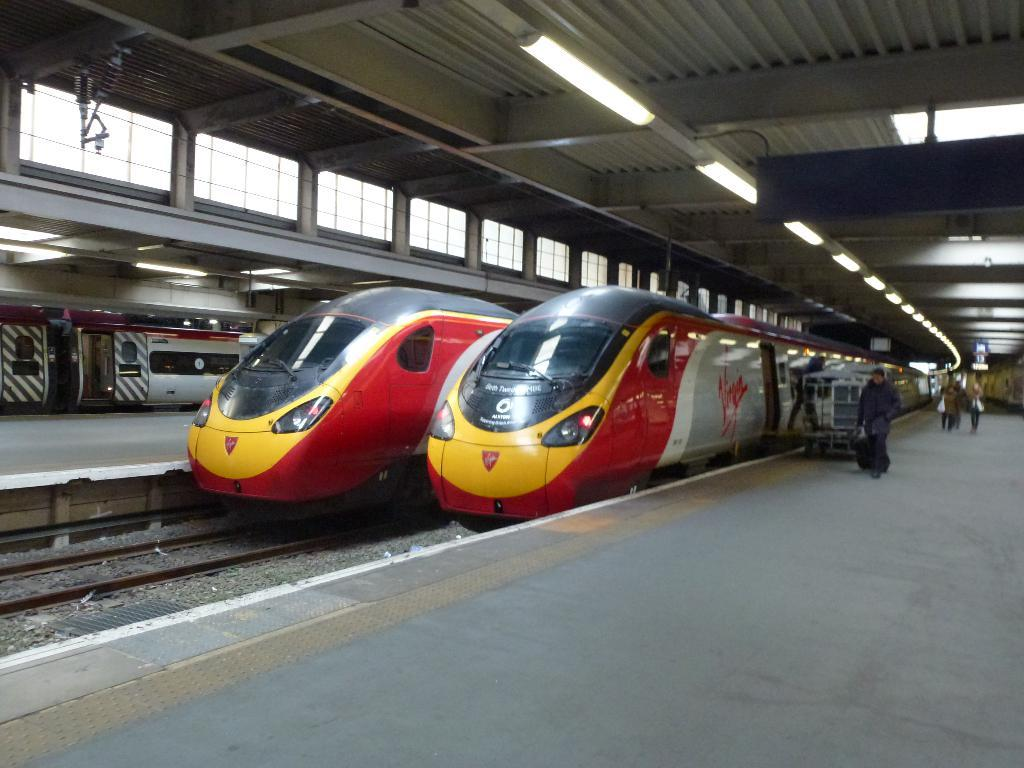Provide a one-sentence caption for the provided image. a train with the word Virgin on the side. 